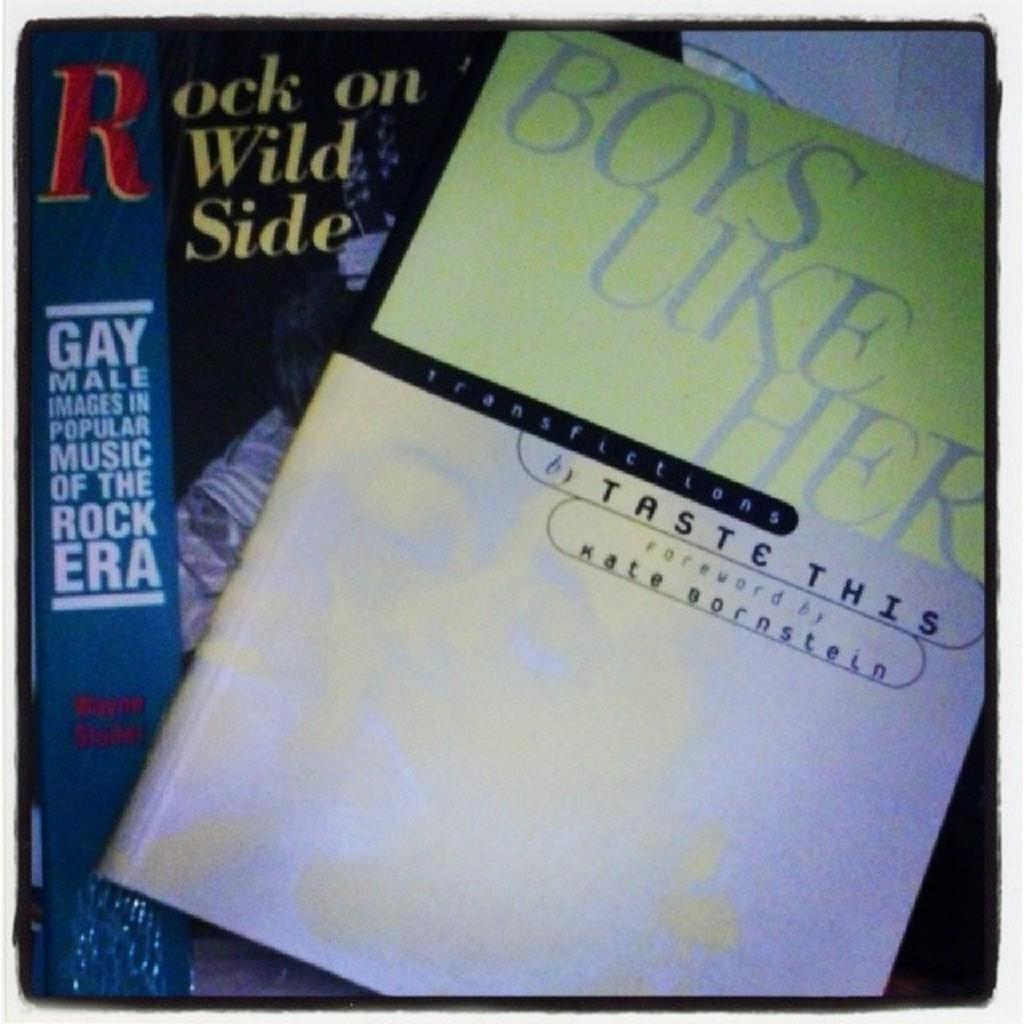<image>
Describe the image concisely. A book titled BOYS LIKE HER by TASTE THIS. 